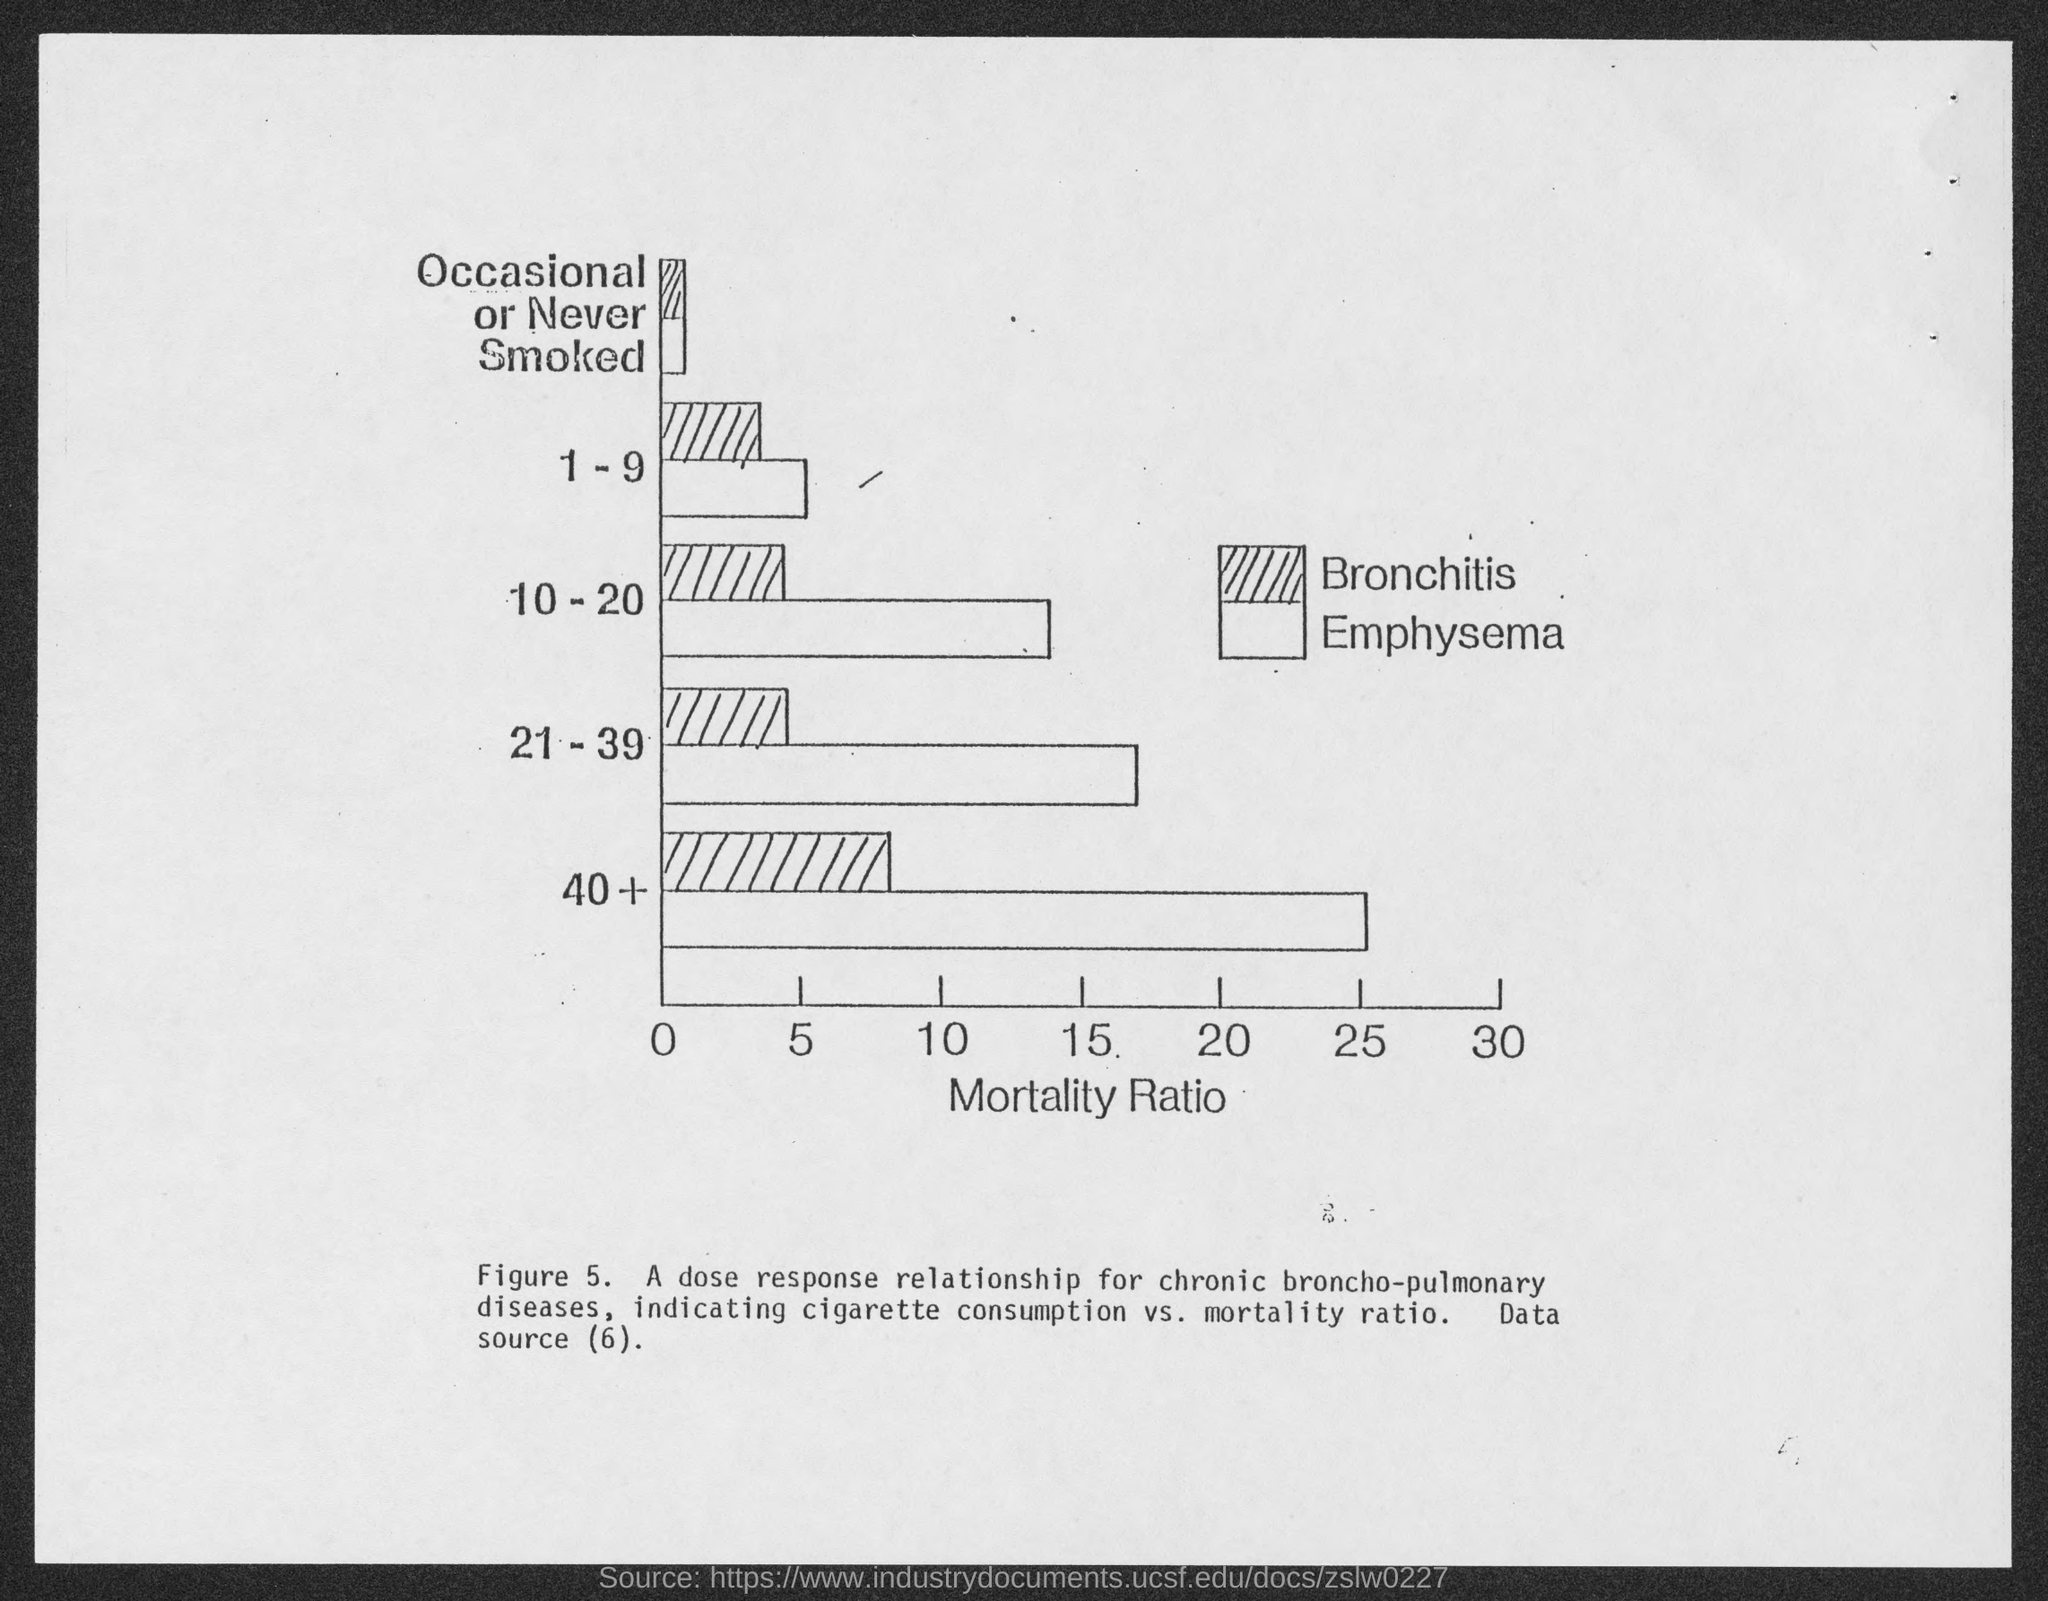Indicate a few pertinent items in this graphic. The figure number is 5. The x-axis in Figure 1 represents the mortality ratio of different populations, which is the number of deaths per 100,000 people in each population. 